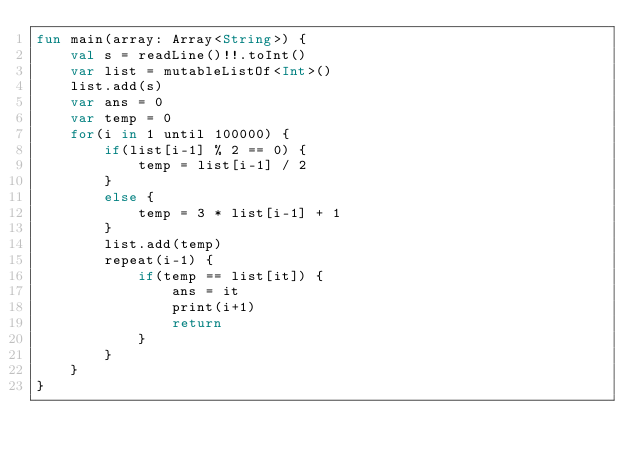<code> <loc_0><loc_0><loc_500><loc_500><_Kotlin_>fun main(array: Array<String>) {
    val s = readLine()!!.toInt()
    var list = mutableListOf<Int>()
    list.add(s)
    var ans = 0
    var temp = 0
    for(i in 1 until 100000) {
        if(list[i-1] % 2 == 0) {
            temp = list[i-1] / 2
        }
        else {
            temp = 3 * list[i-1] + 1
        }
        list.add(temp)
        repeat(i-1) {
            if(temp == list[it]) {
                ans = it
                print(i+1)
                return
            }
        }
    }
}</code> 